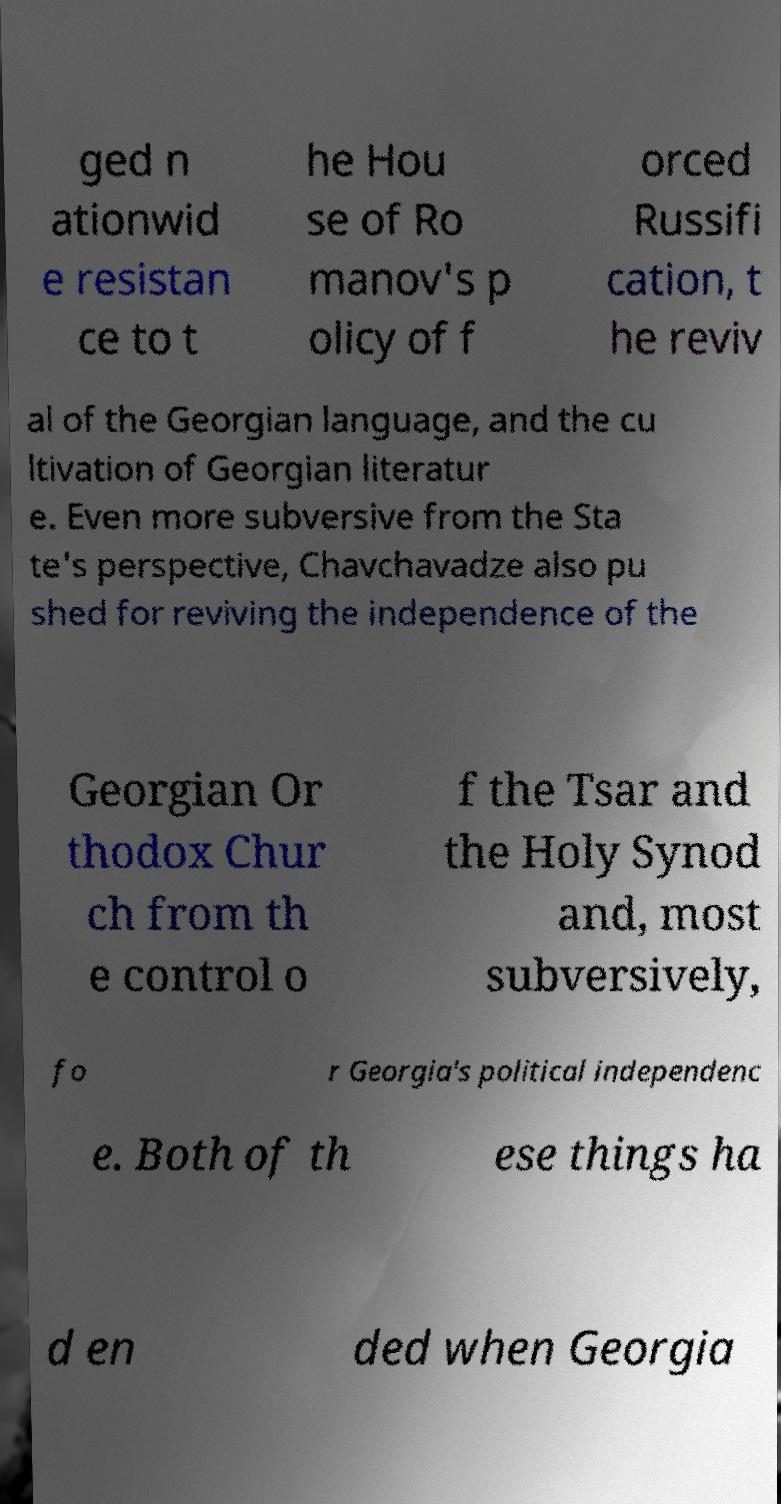There's text embedded in this image that I need extracted. Can you transcribe it verbatim? ged n ationwid e resistan ce to t he Hou se of Ro manov's p olicy of f orced Russifi cation, t he reviv al of the Georgian language, and the cu ltivation of Georgian literatur e. Even more subversive from the Sta te's perspective, Chavchavadze also pu shed for reviving the independence of the Georgian Or thodox Chur ch from th e control o f the Tsar and the Holy Synod and, most subversively, fo r Georgia's political independenc e. Both of th ese things ha d en ded when Georgia 